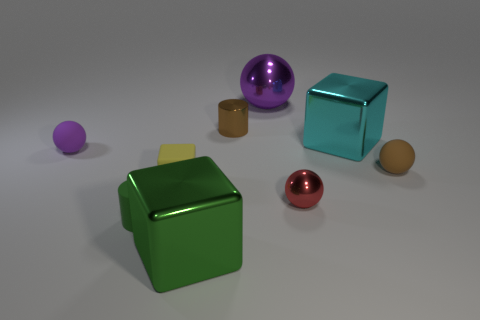The green object in front of the cylinder in front of the rubber sphere behind the small brown matte sphere is what shape?
Your response must be concise. Cube. Does the small red thing have the same shape as the small matte thing to the left of the matte cylinder?
Make the answer very short. Yes. How many small objects are either yellow rubber blocks or green objects?
Provide a short and direct response. 2. Is there another brown metallic thing that has the same size as the brown metal thing?
Your answer should be very brief. No. There is a rubber ball to the left of the tiny metal thing that is to the right of the small cylinder that is right of the small green matte cylinder; what color is it?
Your answer should be very brief. Purple. Is the material of the tiny green thing the same as the tiny brown object that is in front of the large cyan cube?
Provide a short and direct response. Yes. There is a cyan thing that is the same shape as the small yellow thing; what size is it?
Your response must be concise. Large. Are there an equal number of yellow cubes in front of the red metallic sphere and tiny green matte objects to the right of the large purple metal thing?
Give a very brief answer. Yes. How many other things are made of the same material as the tiny brown cylinder?
Give a very brief answer. 4. Is the number of big cyan metallic blocks to the left of the green metallic thing the same as the number of large cylinders?
Offer a very short reply. Yes. 